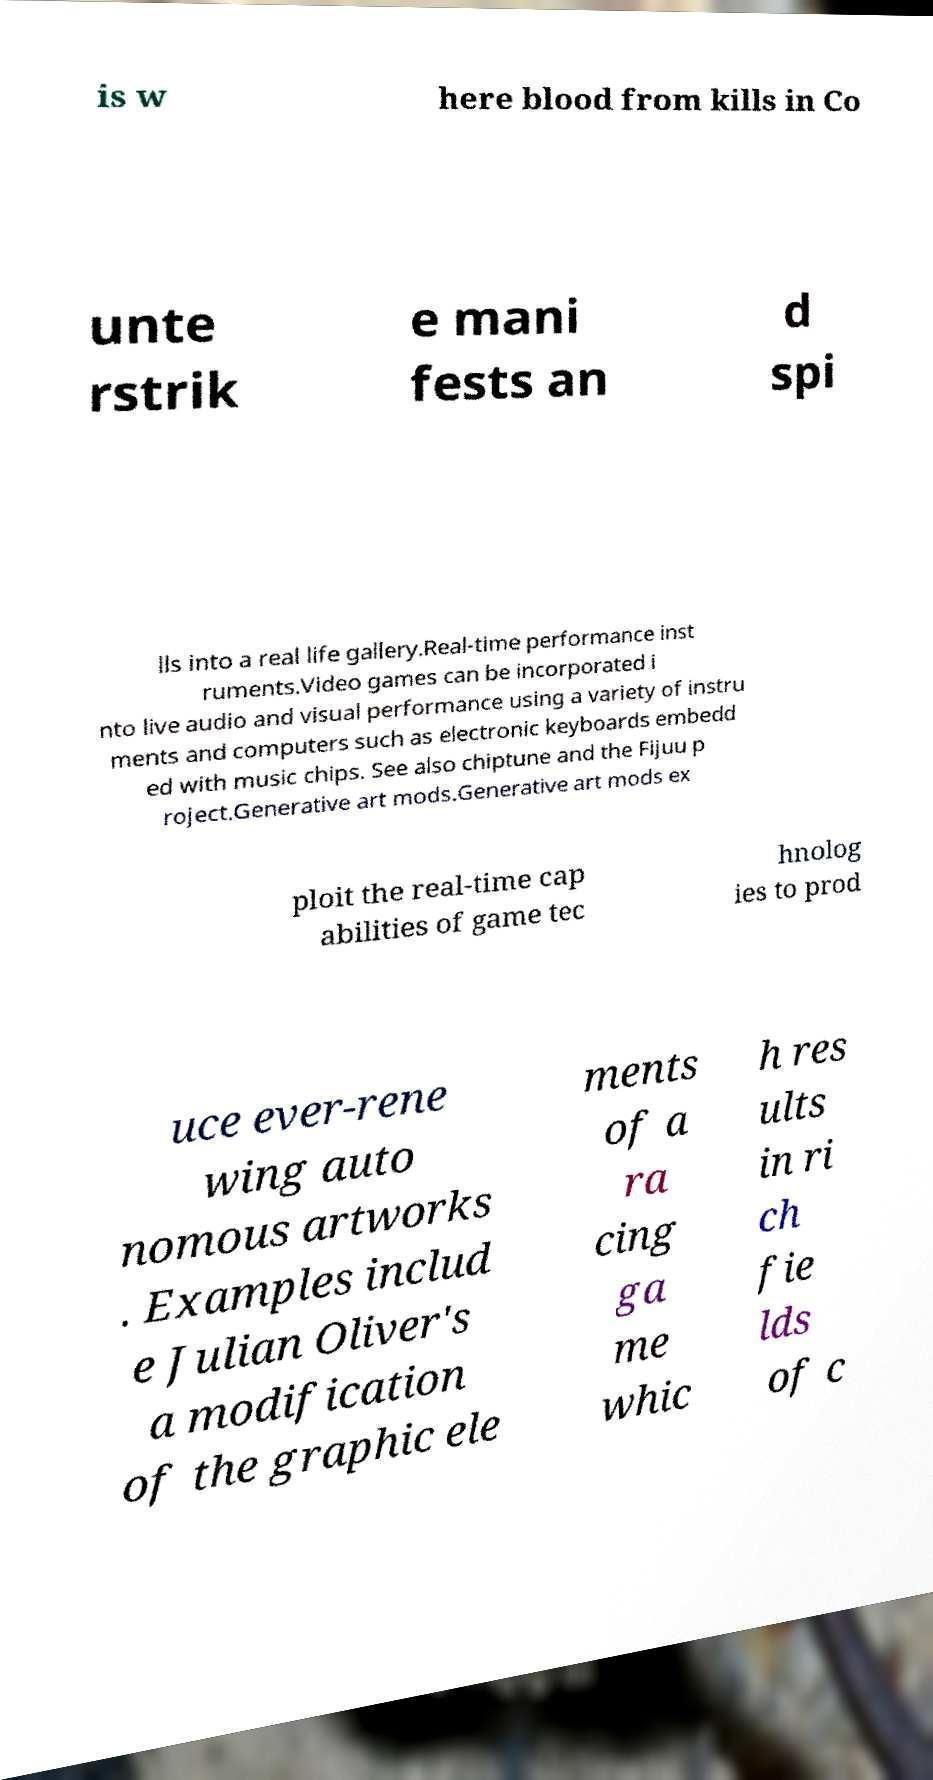There's text embedded in this image that I need extracted. Can you transcribe it verbatim? is w here blood from kills in Co unte rstrik e mani fests an d spi lls into a real life gallery.Real-time performance inst ruments.Video games can be incorporated i nto live audio and visual performance using a variety of instru ments and computers such as electronic keyboards embedd ed with music chips. See also chiptune and the Fijuu p roject.Generative art mods.Generative art mods ex ploit the real-time cap abilities of game tec hnolog ies to prod uce ever-rene wing auto nomous artworks . Examples includ e Julian Oliver's a modification of the graphic ele ments of a ra cing ga me whic h res ults in ri ch fie lds of c 